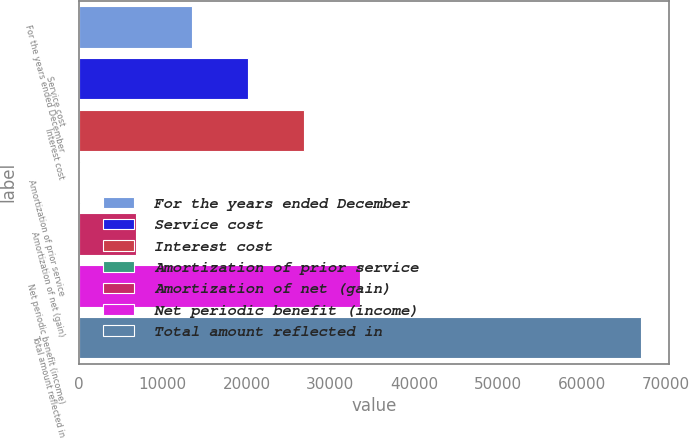<chart> <loc_0><loc_0><loc_500><loc_500><bar_chart><fcel>For the years ended December<fcel>Service cost<fcel>Interest cost<fcel>Amortization of prior service<fcel>Amortization of net (gain)<fcel>Net periodic benefit (income)<fcel>Total amount reflected in<nl><fcel>13527.4<fcel>20215.6<fcel>26903.8<fcel>151<fcel>6839.2<fcel>33592<fcel>67033<nl></chart> 